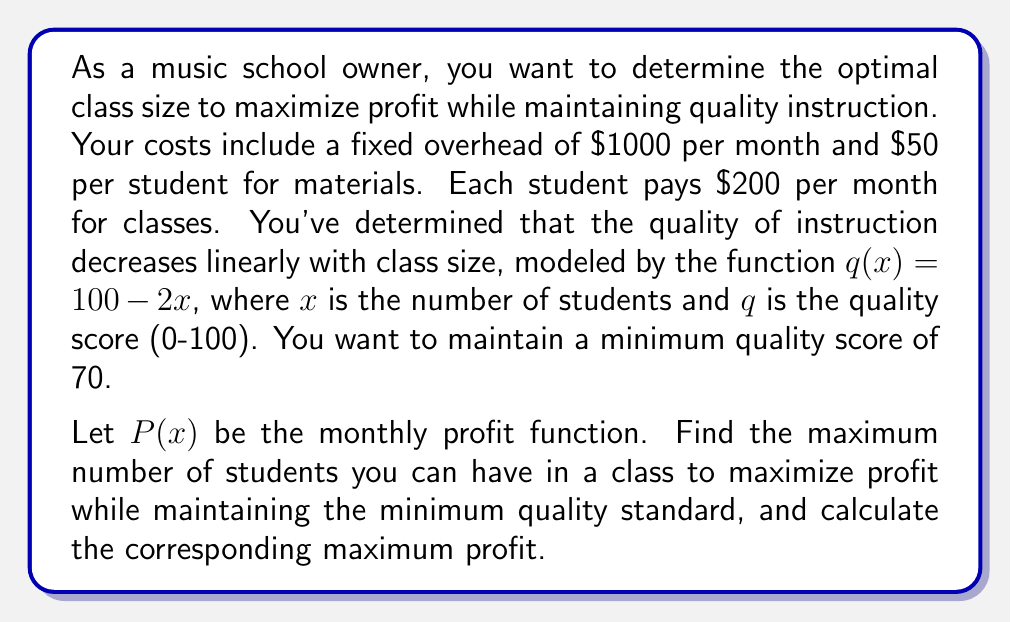What is the answer to this math problem? Let's approach this step-by-step:

1) First, we need to formulate the profit function $P(x)$:
   Revenue = $200x$
   Costs = $1000 + 50x$
   $P(x) = 200x - (1000 + 50x) = 150x - 1000$

2) The quality constraint is:
   $q(x) = 100 - 2x \geq 70$
   $-2x \geq -30$
   $x \leq 15$

3) So, our optimization problem is:
   Maximize $P(x) = 150x - 1000$
   Subject to $x \leq 15$ and $x \geq 0$ (since we can't have negative students)

4) Since $P(x)$ is a linear function with a positive slope, it will reach its maximum at the upper bound of $x$, which is 15.

5) Therefore, the optimal number of students is 15.

6) To calculate the maximum profit:
   $P(15) = 150(15) - 1000 = 2250 - 1000 = 1250$
Answer: The optimal class size is 15 students, which will result in a maximum monthly profit of $1250. 